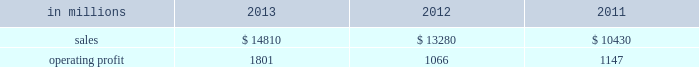Areas exceeding 14.1 million acres ( 5.7 million hectares ) .
Products and brand designations appearing in italics are trademarks of international paper or a related company .
Industry segment results industrial packaging demand for industrial packaging products is closely correlated with non-durable industrial goods production , as well as with demand for processed foods , poultry , meat and agricultural products .
In addition to prices and volumes , major factors affecting the profitability of industrial packaging are raw material and energy costs , freight costs , manufacturing efficiency and product mix .
Industrial packaging net sales and operating profits include the results of the temple-inland packaging operations from the date of acquisition in february 2012 and the results of the brazil packaging business from the date of acquisition in january 2013 .
In addition , due to the acquisition of a majority share of olmuksa international paper sabanci ambalaj sanayi ve ticaret a.s. , ( now called olmuksan international paper or olmuksan ) net sales for our corrugated packaging business in turkey are included in the business segment totals beginning in the first quarter of 2013 and the operating profits reflect a higher ownership percentage than in previous years .
Net sales for 2013 increased 12% ( 12 % ) to $ 14.8 billion compared with $ 13.3 billion in 2012 , and 42% ( 42 % ) compared with $ 10.4 billion in 2011 .
Operating profits were 69% ( 69 % ) higher in 2013 than in 2012 and 57% ( 57 % ) higher than in 2011 .
Excluding costs associated with the acquisition and integration of temple-inland , the divestiture of three containerboard mills and other special items , operating profits in 2013 were 36% ( 36 % ) higher than in 2012 and 59% ( 59 % ) higher than in 2011 .
Benefits from the net impact of higher average sales price realizations and an unfavorable mix ( $ 749 million ) were offset by lower sales volumes ( $ 73 million ) , higher operating costs ( $ 64 million ) , higher maintenance outage costs ( $ 16 million ) and higher input costs ( $ 102 million ) .
Additionally , operating profits in 2013 include costs of $ 62 million associated with the integration of temple-inland , a gain of $ 13 million related to a bargain purchase adjustment on the acquisition of a majority share of our operations in turkey , and a net gain of $ 1 million for other items , while operating profits in 2012 included costs of $ 184 million associated with the acquisition and integration of temple-inland , mill divestiture costs of $ 91 million , costs associated with the restructuring of our european packaging business of $ 17 million and a $ 3 million gain for other items .
Industrial packaging .
North american industrial packaging net sales were $ 12.5 billion in 2013 compared with $ 11.6 billion in 2012 and $ 8.6 billion in 2011 .
Operating profits in 2013 were $ 1.8 billion ( both including and excluding costs associated with the integration of temple-inland and other special items ) compared with $ 1.0 billion ( $ 1.3 billion excluding costs associated with the acquisition and integration of temple-inland and mill divestiture costs ) in 2012 and $ 1.1 billion ( both including and excluding costs associated with signing an agreement to acquire temple-inland ) in 2011 .
Sales volumes decreased in 2013 compared with 2012 reflecting flat demand for boxes and the impact of commercial decisions .
Average sales price realizations were significantly higher mainly due to the realization of price increases for domestic containerboard and boxes .
Input costs were higher for wood , energy and recycled fiber .
Freight costs also increased .
Planned maintenance downtime costs were higher than in 2012 .
Manufacturing operating costs decreased , but were offset by inflation and higher overhead and distribution costs .
The business took about 850000 tons of total downtime in 2013 of which about 450000 were market- related and 400000 were maintenance downtime .
In 2012 , the business took about 945000 tons of total downtime of which about 580000 were market-related and about 365000 were maintenance downtime .
Operating profits in 2013 included $ 62 million of costs associated with the integration of temple-inland .
Operating profits in 2012 included $ 184 million of costs associated with the acquisition and integration of temple-inland and $ 91 million of costs associated with the divestiture of three containerboard mills .
Looking ahead to 2014 , compared with the fourth quarter of 2013 , sales volumes in the first quarter are expected to increase for boxes due to a higher number of shipping days offset by the impact from the severe winter weather events impacting much of the u.s .
Input costs are expected to be higher for energy , recycled fiber , wood and starch .
Planned maintenance downtime spending is expected to be about $ 51 million higher with outages scheduled at six mills compared with four mills in the 2013 fourth quarter .
Manufacturing operating costs are expected to be lower .
However , operating profits will be negatively impacted by the adverse winter weather in the first quarter of 2014 .
Emea industrial packaging net sales in 2013 include the sales of our packaging operations in turkey which are now fully consolidated .
Net sales were $ 1.3 billion in 2013 compared with $ 1.0 billion in 2012 and $ 1.1 billion in 2011 .
Operating profits in 2013 were $ 43 million ( $ 32 .
What was the profit margin in 2011? 
Computations: (1147 / 10430)
Answer: 0.10997. 